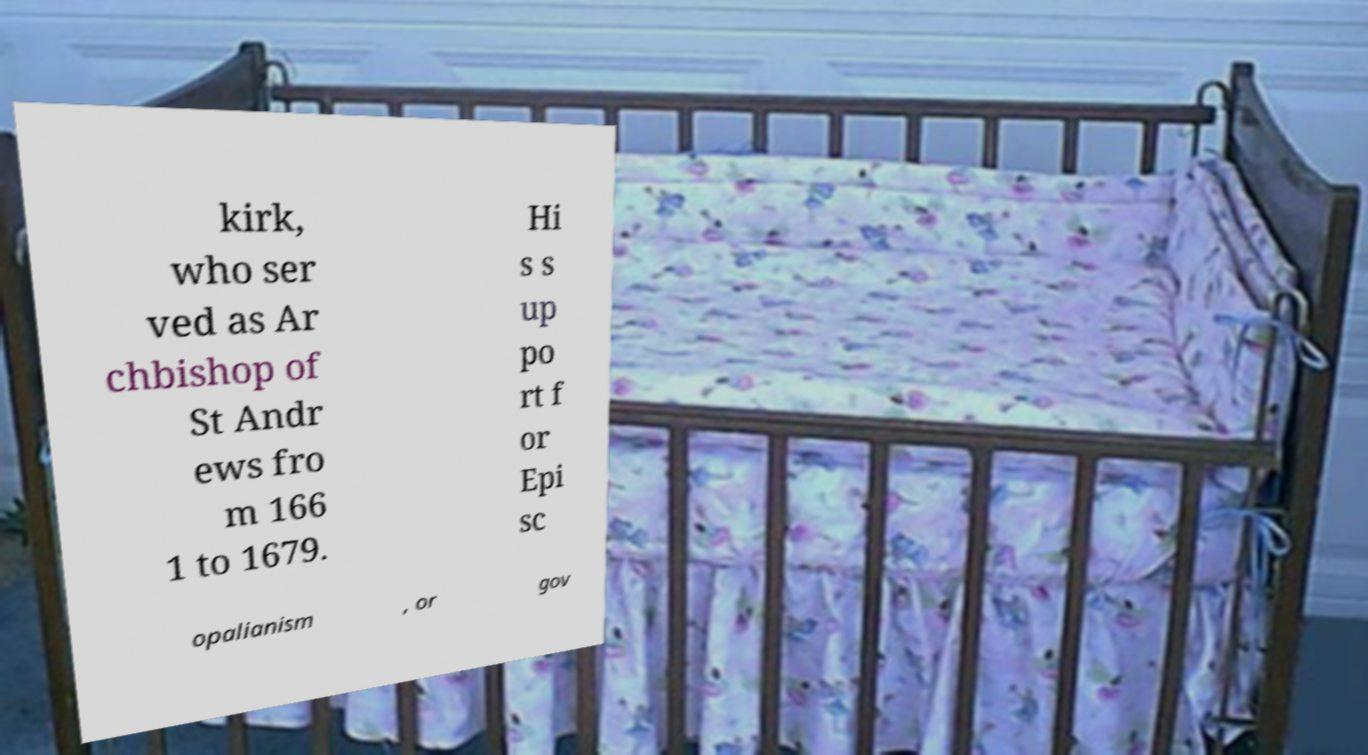Could you assist in decoding the text presented in this image and type it out clearly? kirk, who ser ved as Ar chbishop of St Andr ews fro m 166 1 to 1679. Hi s s up po rt f or Epi sc opalianism , or gov 